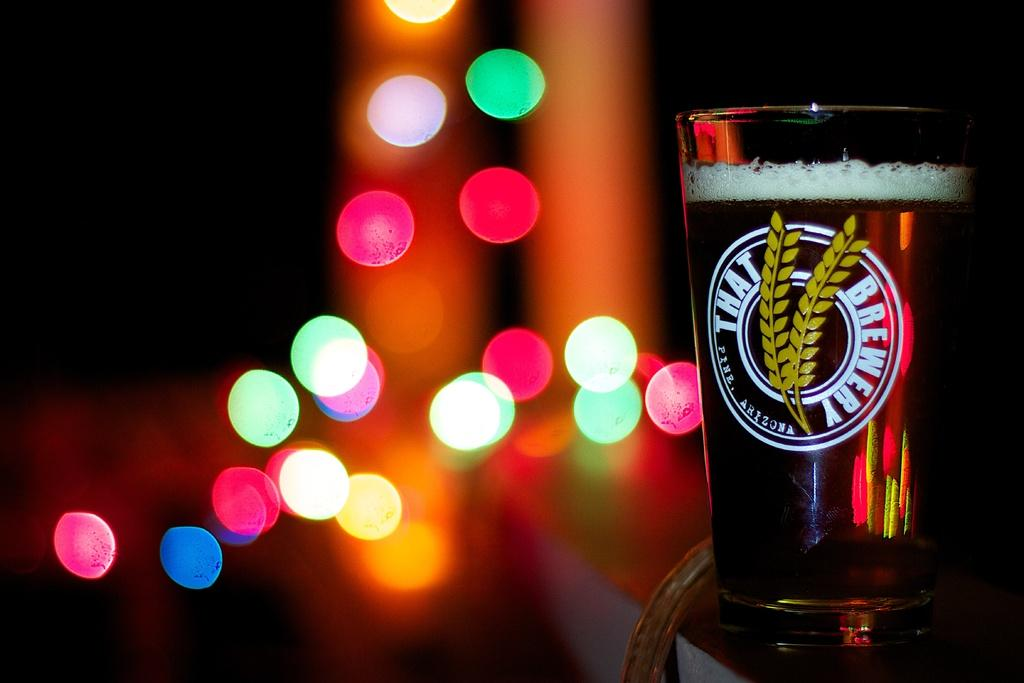<image>
Render a clear and concise summary of the photo. A That Brewery logo is etched onto a glass of beer in a well-lit area. 